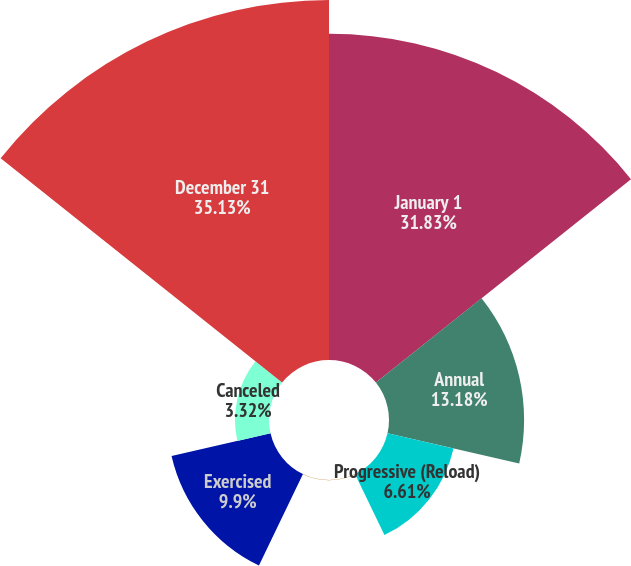Convert chart to OTSL. <chart><loc_0><loc_0><loc_500><loc_500><pie_chart><fcel>January 1<fcel>Annual<fcel>Progressive (Reload)<fcel>Other<fcel>Exercised<fcel>Canceled<fcel>December 31<nl><fcel>31.83%<fcel>13.18%<fcel>6.61%<fcel>0.03%<fcel>9.9%<fcel>3.32%<fcel>35.12%<nl></chart> 